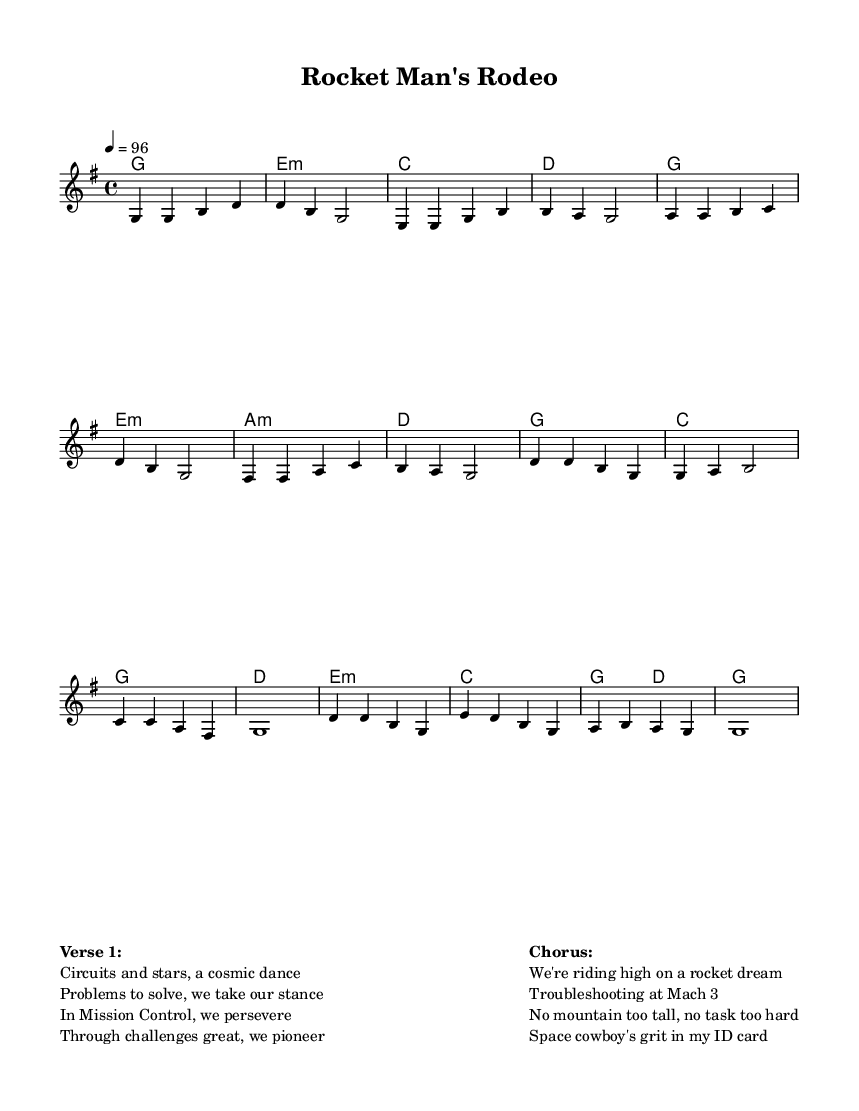What is the key signature of this music? The key signature is G major, which has one sharp (F#). You can determine this by looking at the beginning of the score, where the key signatures are indicated.
Answer: G major What is the time signature of this music? The time signature is 4/4, which is a common time signature indicating that there are four beats in each measure and a quarter note receives one beat. This can be seen at the beginning of the score next to the key signature.
Answer: 4/4 What is the tempo of this piece? The tempo is marked as quarter note = 96, indicating the speed of the music. This means there are 96 quarter notes played in a minute, which is a steady moderate pace for the song.
Answer: 96 How many measures are there in the verse? There are eight measures in the verse. You can count the measures by looking at the vertical lines that separate different sections of music.
Answer: 8 What chord follows the F# note in the verse? The chord that follows the F# note in the verse is A minor (a:m). This can be found by looking at the chord names that are written above the melody notes in the verse section.
Answer: A minor What themes are represented in the lyrics of the song? The themes of perseverance and problem-solving are present in the lyrics, as they talk about tackling cosmic challenges and maintaining a sense of determination. You can identify the themes by analyzing the words in the verses and the chorus.
Answer: Perseverance, problem-solving What is the lyrical content of the chorus focused on? The lyrical content of the chorus is focused on achieving dreams through grit and determination in challenging circumstances. It reflects a positive and ambitious attitude while addressing the struggles faced. This can be determined by closely reading the lines of the chorus provided in the markup section.
Answer: Rocket dream, troubleshooting, grit 